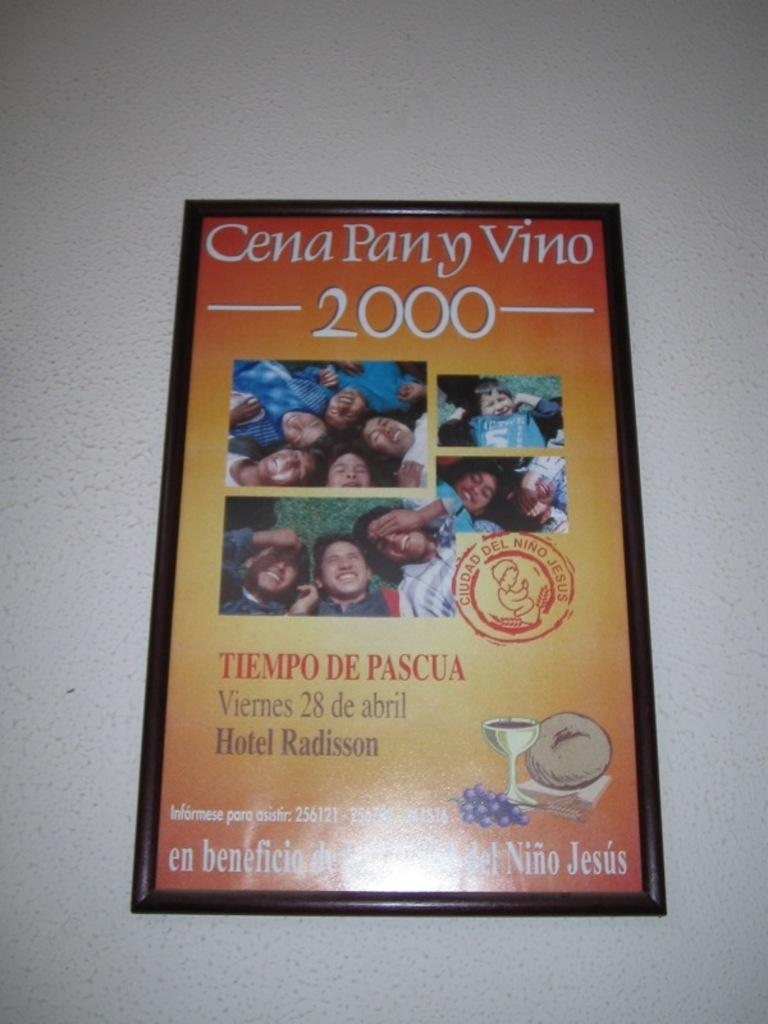<image>
Offer a succinct explanation of the picture presented. a framed picture advertising cena pany vino 2000 